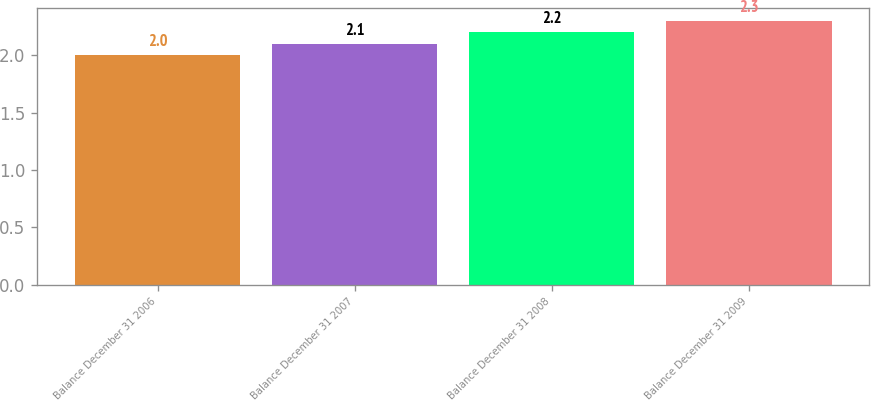<chart> <loc_0><loc_0><loc_500><loc_500><bar_chart><fcel>Balance December 31 2006<fcel>Balance December 31 2007<fcel>Balance December 31 2008<fcel>Balance December 31 2009<nl><fcel>2<fcel>2.1<fcel>2.2<fcel>2.3<nl></chart> 